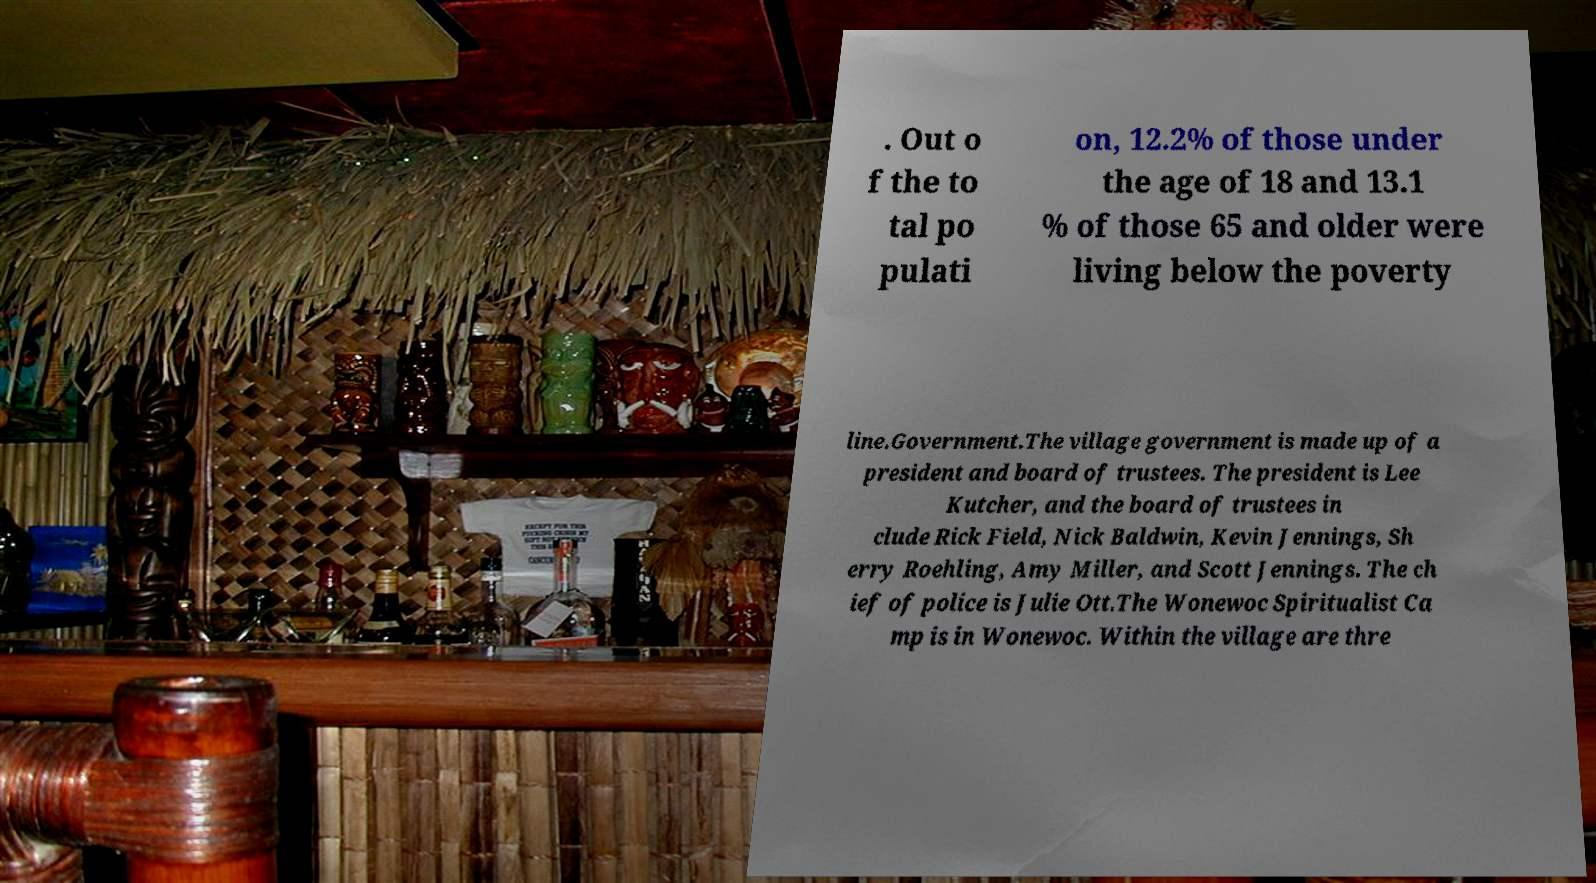I need the written content from this picture converted into text. Can you do that? . Out o f the to tal po pulati on, 12.2% of those under the age of 18 and 13.1 % of those 65 and older were living below the poverty line.Government.The village government is made up of a president and board of trustees. The president is Lee Kutcher, and the board of trustees in clude Rick Field, Nick Baldwin, Kevin Jennings, Sh erry Roehling, Amy Miller, and Scott Jennings. The ch ief of police is Julie Ott.The Wonewoc Spiritualist Ca mp is in Wonewoc. Within the village are thre 